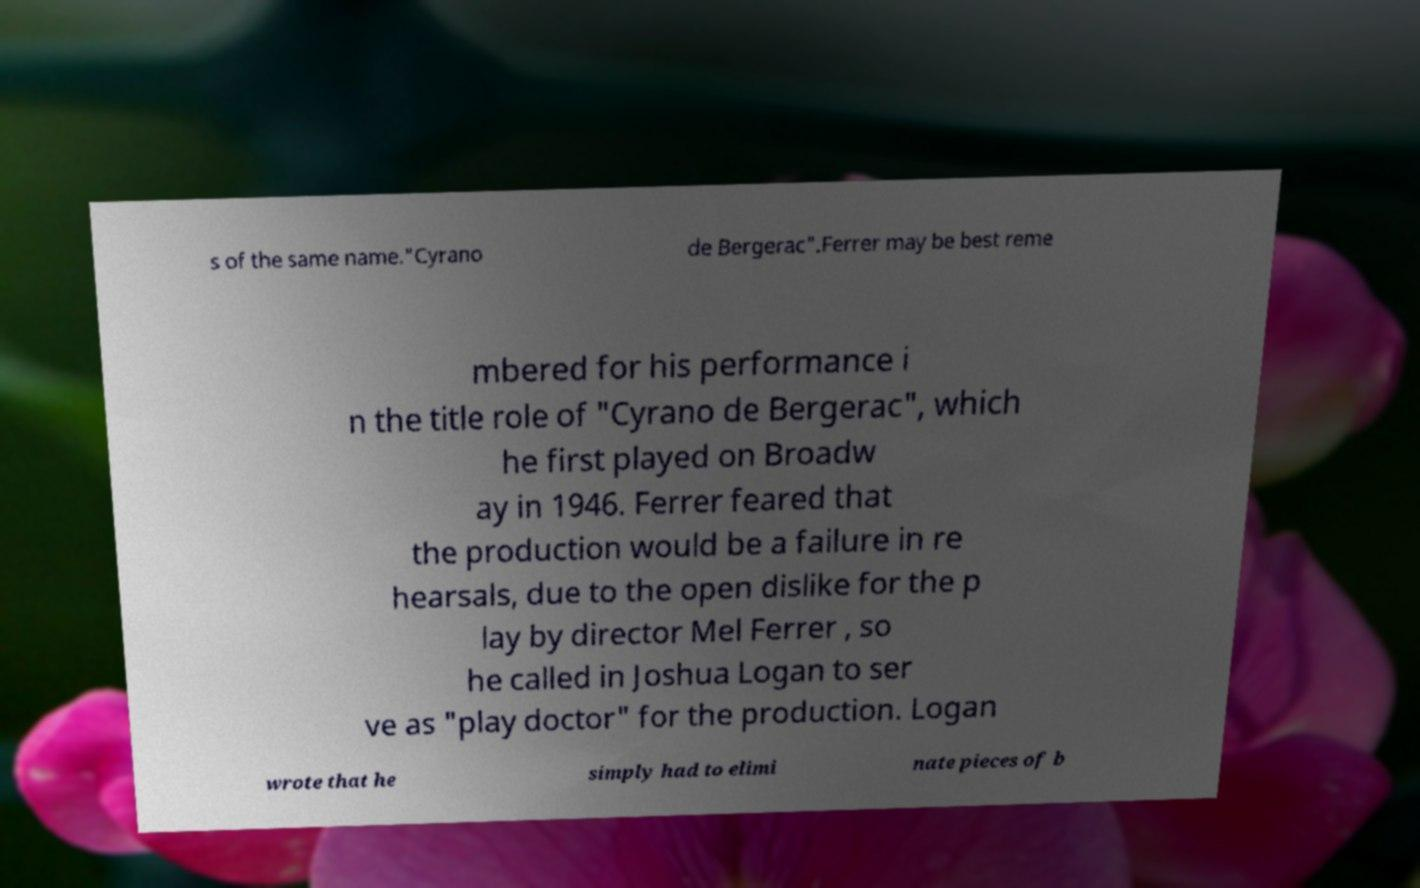I need the written content from this picture converted into text. Can you do that? s of the same name."Cyrano de Bergerac".Ferrer may be best reme mbered for his performance i n the title role of "Cyrano de Bergerac", which he first played on Broadw ay in 1946. Ferrer feared that the production would be a failure in re hearsals, due to the open dislike for the p lay by director Mel Ferrer , so he called in Joshua Logan to ser ve as "play doctor" for the production. Logan wrote that he simply had to elimi nate pieces of b 